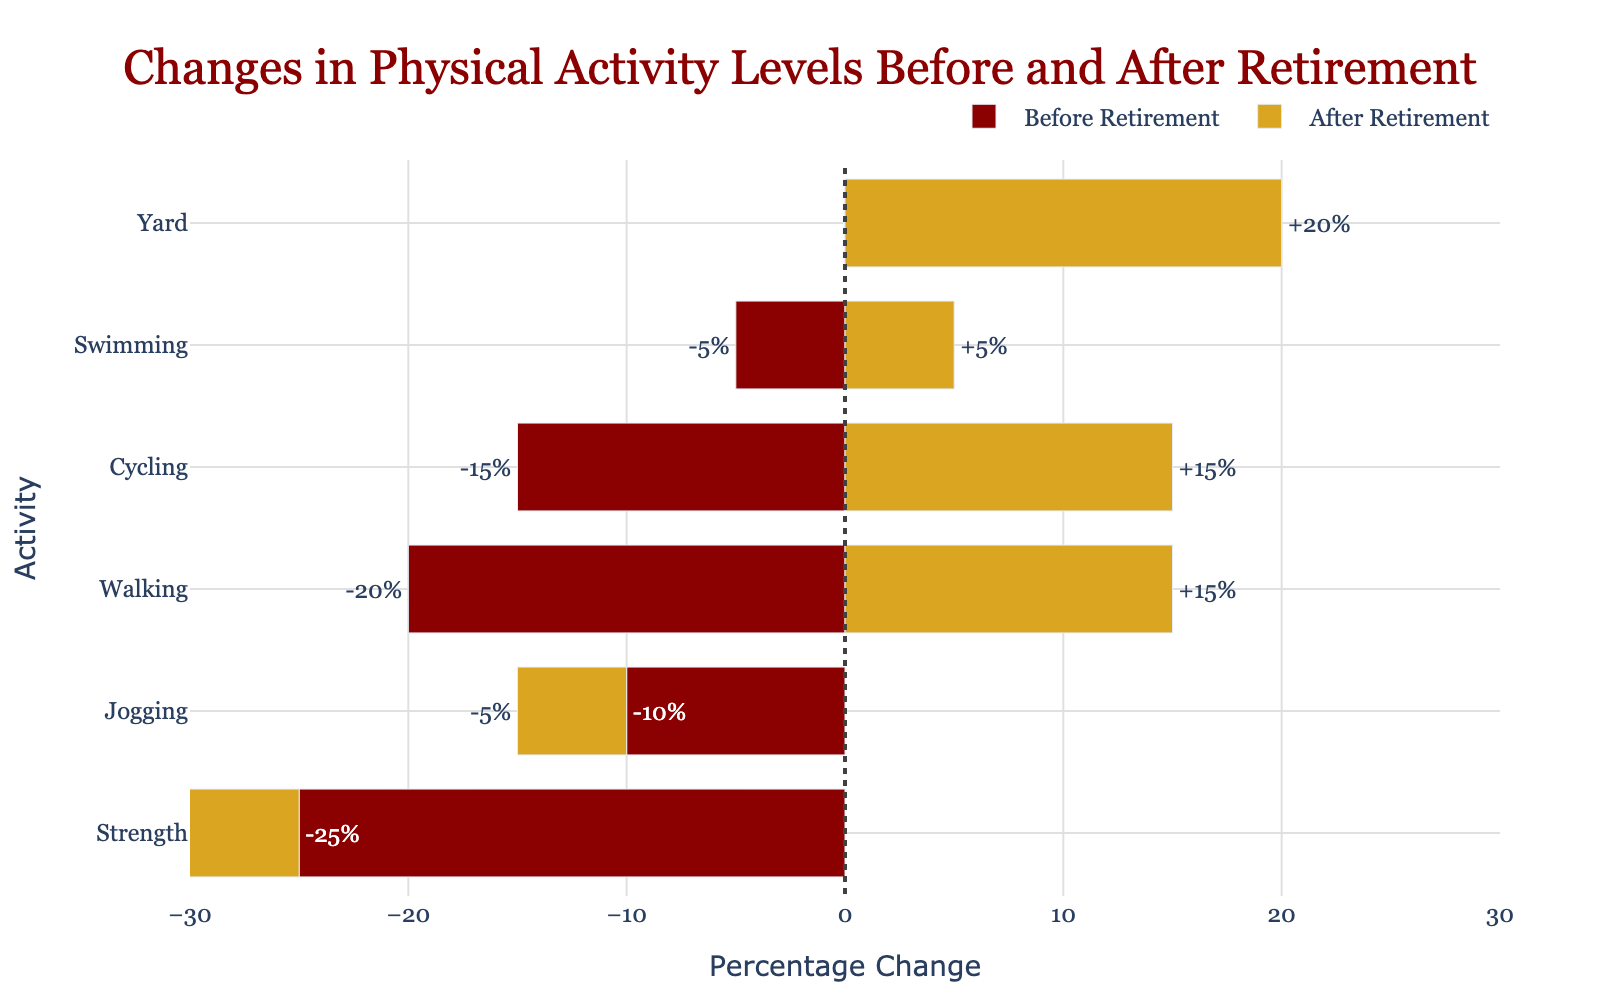How much did yard work activity increase after retirement compared to before retirement? The yard work activity is shown as an increase of 20% after retirement, and it was maintained (0% change) before retirement. To find the increase, we subtract the before value from the after value: \(20\% - 0\% = 20\%\)
Answer: 20% What is the total decrease in strength training before and after retirement? The strength training activity decreased by 25% before retirement and by 10% after retirement. Adding these two decreases together gives us the total decrease: \(-25\% - 10\% = -35\%\)
Answer: -35% Which activity had the highest increase after retirement? By examining the bars labeled with increases after retirement, we see that yard work had the highest increase, with a 20% increase.
Answer: Yard work Was the change in cycling activity from before to after retirement greater than the change in swimming activity during the same periods? Before retirement, cycling had a change of -15% and after retirement, it had a change of +15%, resulting in a total change of \( -15\% + 15\% = 30\% \). Swimming had a change of -5% before retirement and +5% after retirement, yielding a total change of \( -5\% + 5\% = 10\% \). Thus, the change in cycling is greater than in swimming.
Answer: Yes How does the change in walking activity after retirement compare to the change in jogging activity after retirement? The walking activity increased by 15% after retirement, while the jogging activity decreased by 5% after retirement, indicating that walking saw a positive change while jogging saw a negative change.
Answer: Walking increased, jogging decreased Which period showed a larger decrease for strength training, before or after retirement? By comparing the strength training bars, we see that before retirement had a decrease of 25%, and after retirement had a decrease of 10%. Therefore, the period before retirement shows a larger decrease in strength training.
Answer: Before retirement What is the combined change in cycling activity before and after retirement? The change in cycling before retirement is -15%, and after retirement, it is +15%. Adding these changes together: \(-15\% + 15\% = 0\%\). Thus, the combined change in cycling is 0%.
Answer: 0% Compare the combined change in jogging and swimming before retirement. Which had a larger decrease? Before retirement, jogging had a decrease of 10% and swimming had a decrease of 5%. Therefore, the combined decrease for jogging and swimming is: \( -10\% + -5\% = -15\% \). Comparing these values directly, jogging had the larger decrease at -10%, compared to swimming's -5%.
Answer: Jogging What is the net change in physical activities (considering all listed activities) through the retirement period? Summing up all changes before retirement: \(-20 - 10 - 25 - 15 - 5 + 0 = -75\). Summing up all changes after retirement: \( 15 - 5 -10 + 15 + 5 + 20 = 40\). The net change: \( -75 + 40 = -35\). Therefore, the net change in physical activities is -35%.
Answer: -35% 